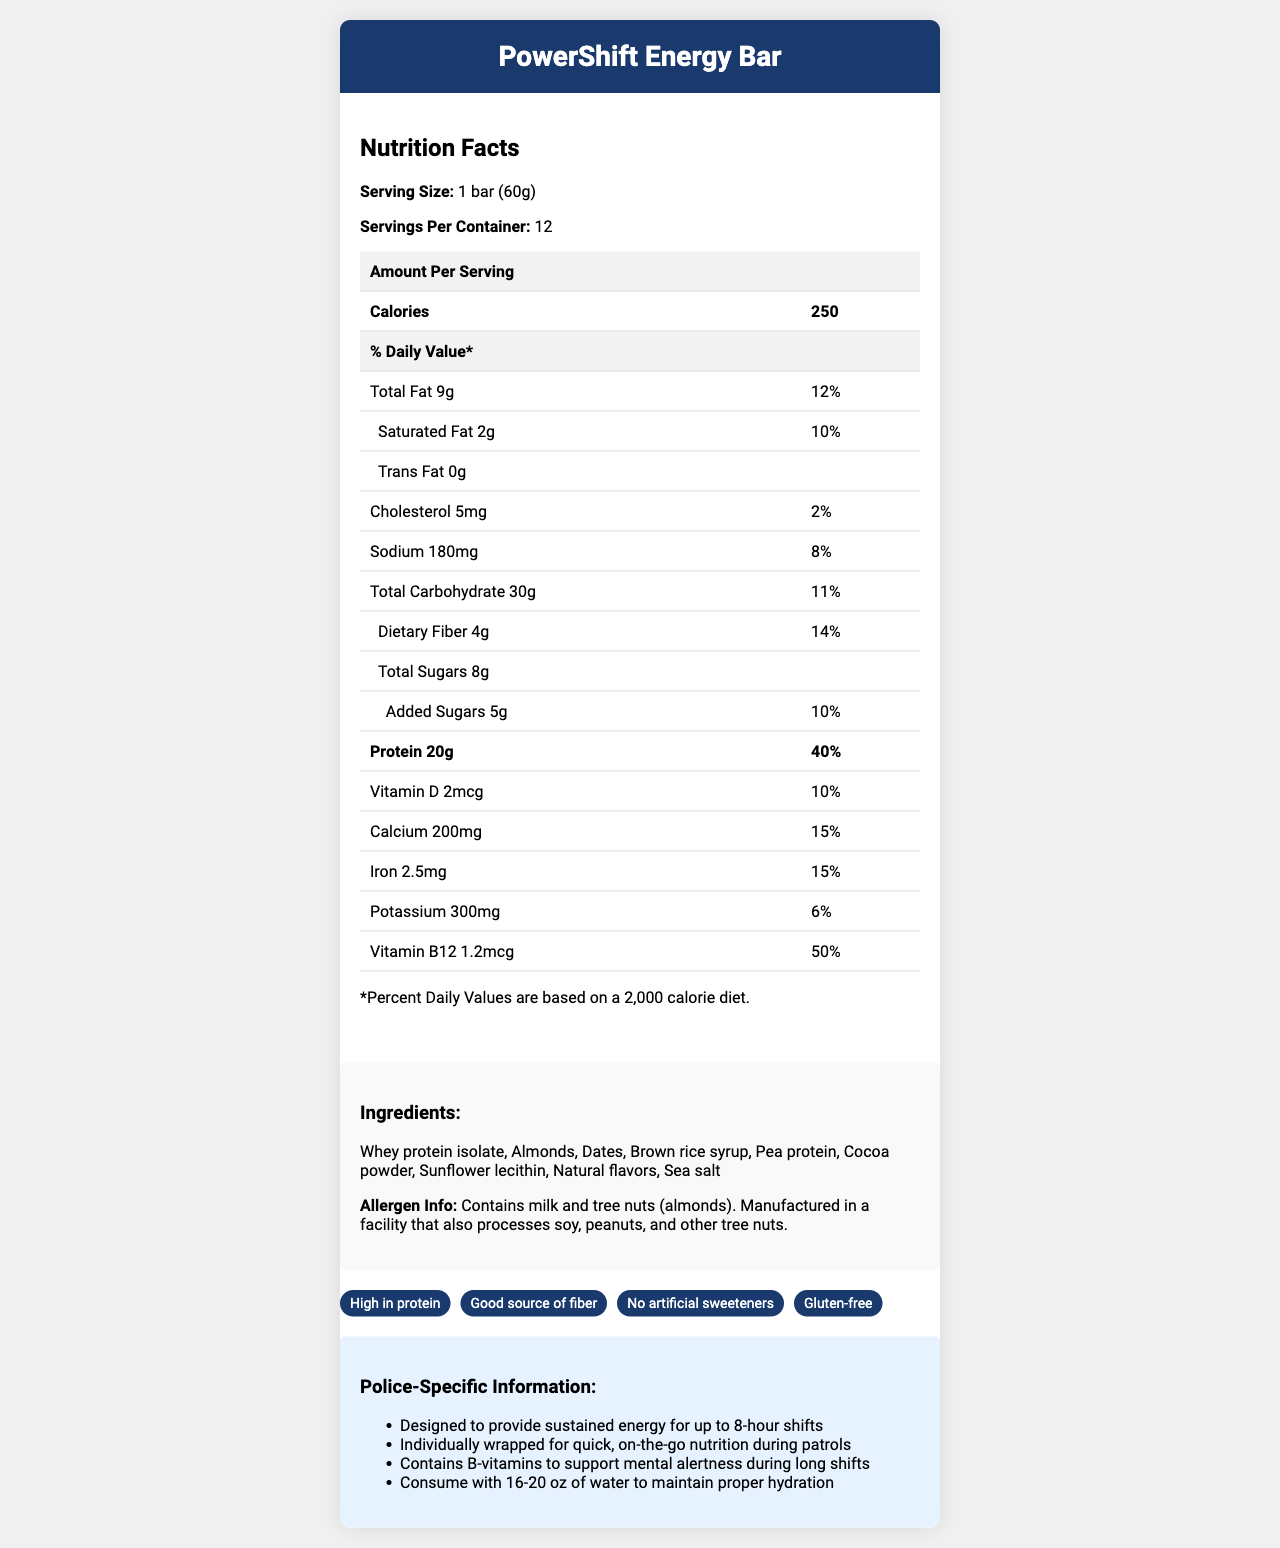what is the serving size? The serving size is stated as "1 bar (60g)" in the Nutrition Facts section.
Answer: 1 bar (60g) how many servings are in each container? The number of servings per container is shown as 12.
Answer: 12 how many calories does one PowerShift Energy Bar contain? The document specifies that one bar contains 250 calories.
Answer: 250 how much protein is in one serving? The amount of protein per serving is listed as 20g in the Nutrition Facts.
Answer: 20g list three main ingredients in the PowerShift Energy Bar. These ingredients are among the first listed in the Ingredients section.
Answer: Whey protein isolate, Almonds, Dates how much dietary fiber is in one bar? The amount of dietary fiber per serving is listed as 4g in the Nutrition Facts.
Answer: 4g What percent of the daily value for protein does one bar provide? The document shows that one bar provides 40% of the daily value for protein.
Answer: 40% which of the following is NOT an ingredient in the PowerShift Energy Bar? A. Whey protein isolate B. Almonds C. Soy protein D. Brown rice syrup Soy protein is not listed in the ingredients; the correct protein listed is whey protein isolate and pea protein.
Answer: C. Soy protein which vitamin has the highest percent daily value in the PowerShift Energy Bar? A. Vitamin D B. Calcium C. Iron D. Vitamin B12 Vitamin B12 has a 50% daily value, the highest among the listed vitamins and minerals.
Answer: D. Vitamin B12 does the PowerShift Energy Bar contain any artificial sweeteners? The product claims indicate "No artificial sweeteners."
Answer: No is this product gluten-free? One of the product claims is "Gluten-free."
Answer: Yes how does the PowerShift Energy Bar support cognitive function during long shifts? The Police-Specific Information section mentions that B-vitamins in the bar support mental alertness.
Answer: Contains B-vitamins to support mental alertness is there any tree nut in the PowerShift Energy Bar? The allergen info states that it contains tree nuts (almonds).
Answer: Yes describe the main idea of the document. The document provides detailed nutritional information of the bar, lists its ingredients and allergens, and outlines benefits for police, making it suitable for long and demanding shifts.
Answer: This document describes the nutritional facts of the PowerShift Energy Bar, highlighting its protein content, ingredients, allergen information, and specific benefits for police officers, such as sustained energy for long shifts and support for mental alertness. how many bars are in a single container? The number of bars per container is not explicitly given in the visual information; only the number of servings per container is shown.
Answer: Cannot be determined 